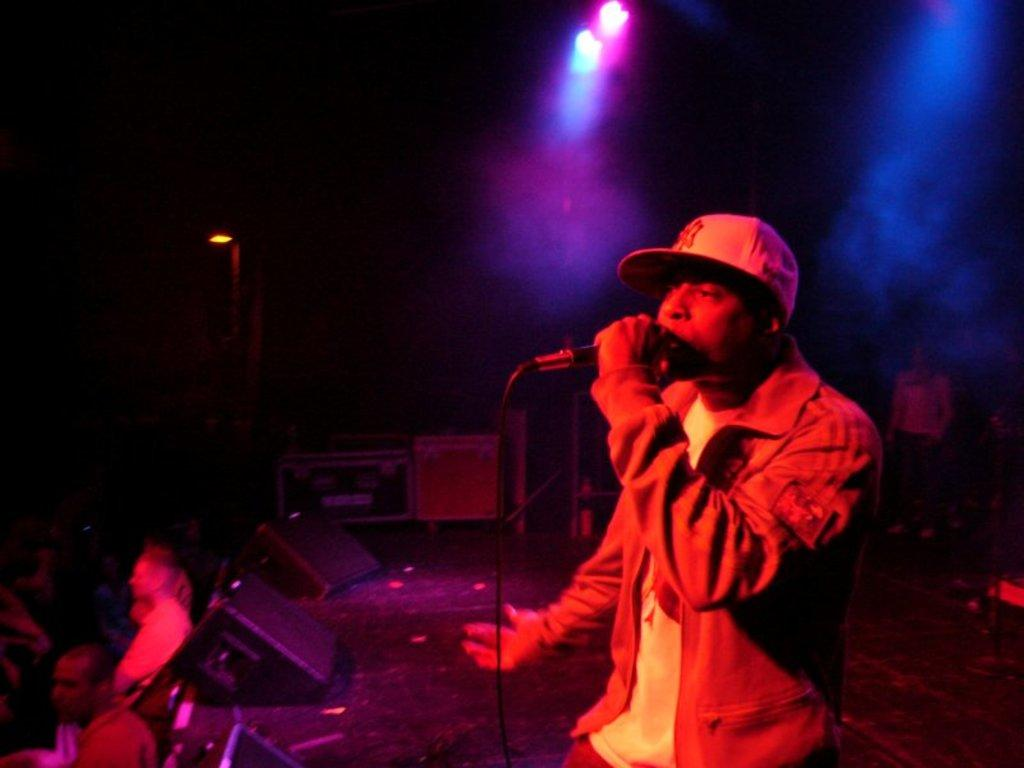What is the man in the image doing? The man is singing in a microphone. What is the man wearing in the image? The man is wearing a coat and a cap. What can be seen at the top of the image? There are focus lights at the top of the image. Are there any other people visible in the image? Yes, there are people on the left-hand side of the image. What type of wheel is being used for transportation in the image? There is no wheel or transportation device present in the image. Is the man singing at an airport in the image? There is no indication of an airport or any airport-related activities in the image. 